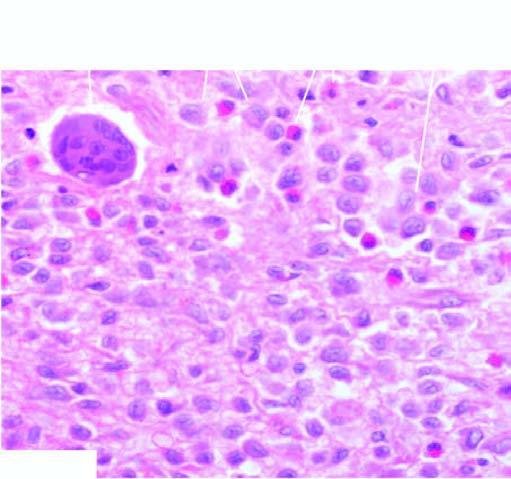does bone biopsy show presence of infiltrate by collections of histiocytes having vesicular nuclei admixed with eosinophils?
Answer the question using a single word or phrase. Yes 